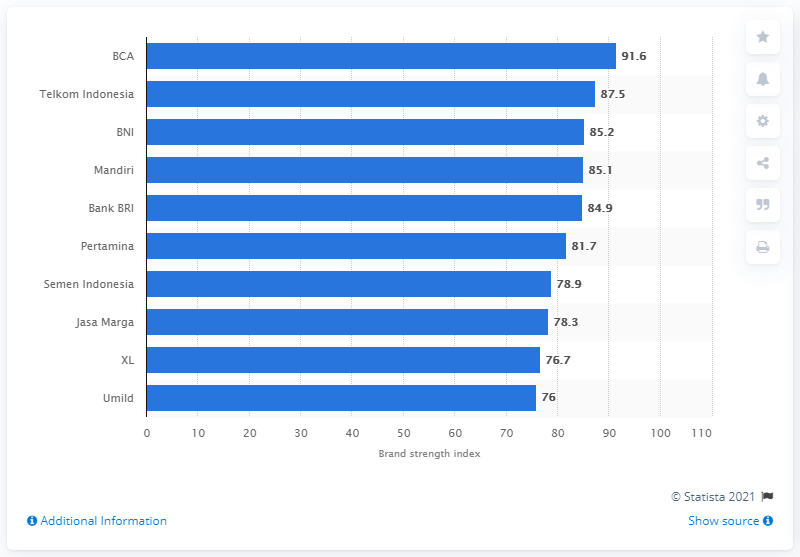Indicate a few pertinent items in this graphic. Bank Central Asia's brand strength index was 91.6. 